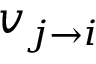Convert formula to latex. <formula><loc_0><loc_0><loc_500><loc_500>v _ { j \rightarrow i }</formula> 